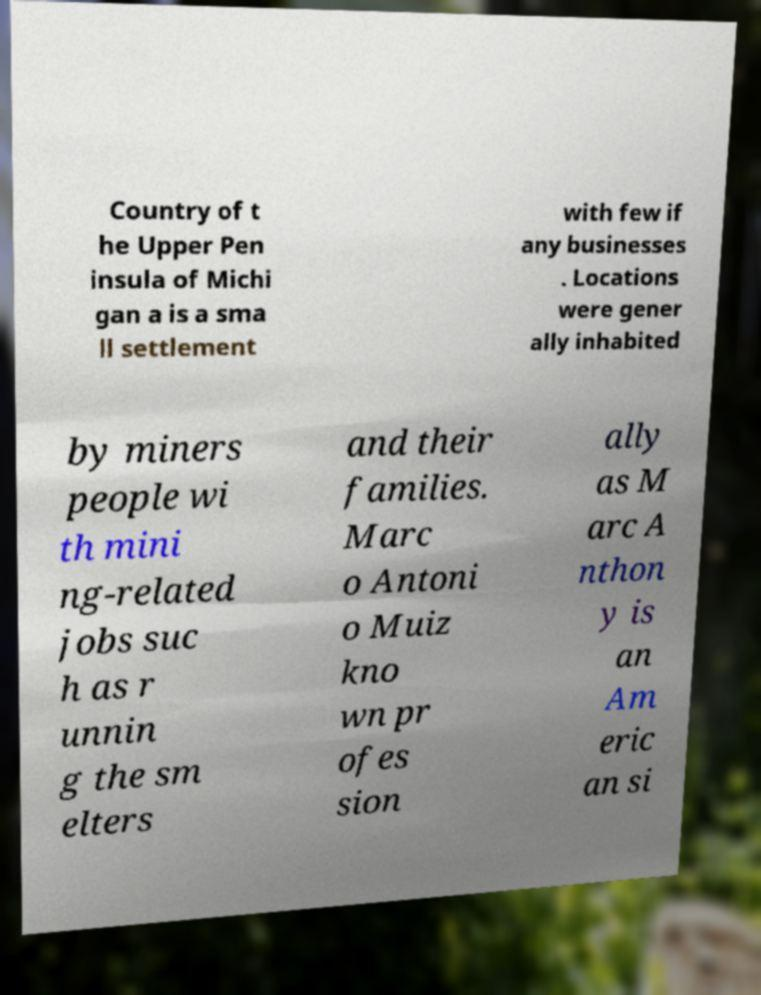What messages or text are displayed in this image? I need them in a readable, typed format. Country of t he Upper Pen insula of Michi gan a is a sma ll settlement with few if any businesses . Locations were gener ally inhabited by miners people wi th mini ng-related jobs suc h as r unnin g the sm elters and their families. Marc o Antoni o Muiz kno wn pr ofes sion ally as M arc A nthon y is an Am eric an si 